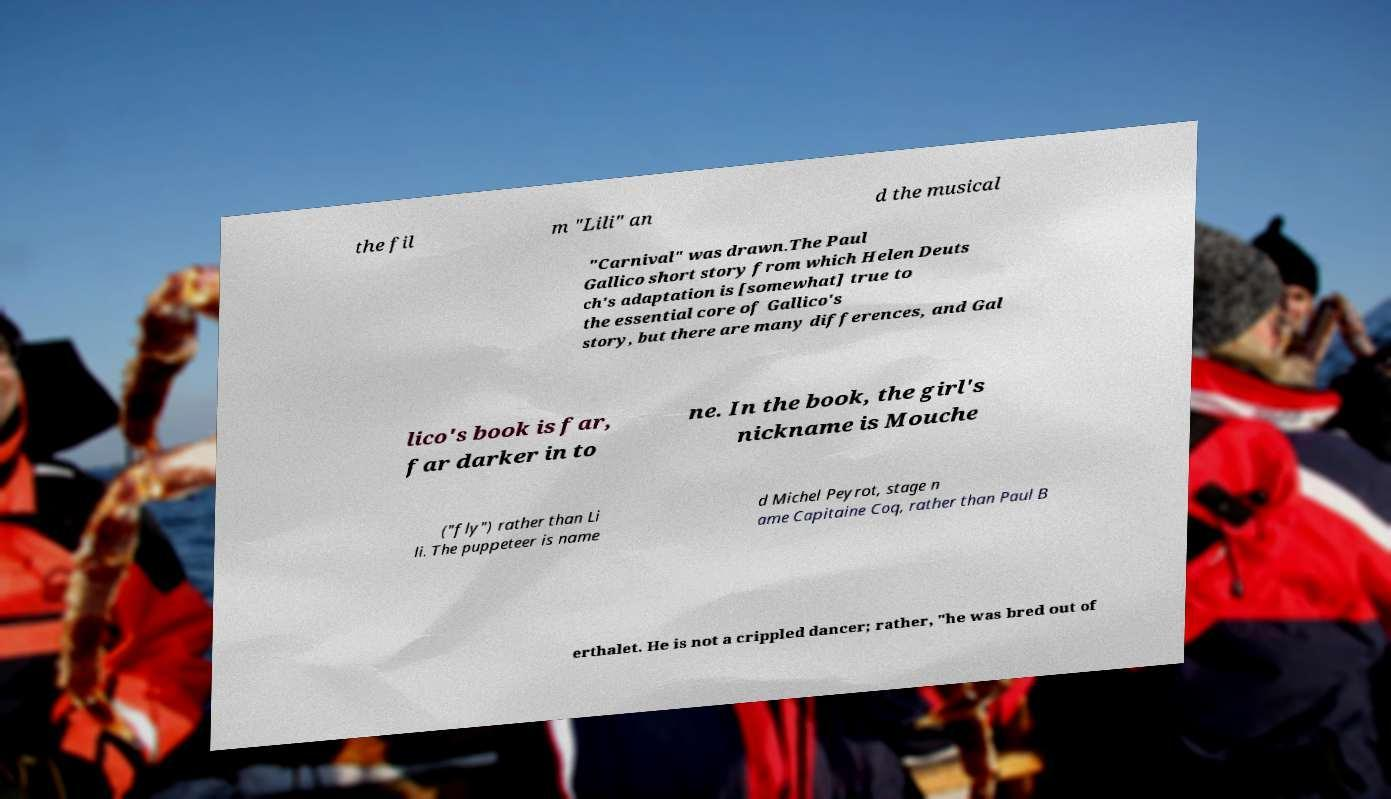Can you read and provide the text displayed in the image?This photo seems to have some interesting text. Can you extract and type it out for me? the fil m "Lili" an d the musical "Carnival" was drawn.The Paul Gallico short story from which Helen Deuts ch's adaptation is [somewhat] true to the essential core of Gallico's story, but there are many differences, and Gal lico's book is far, far darker in to ne. In the book, the girl's nickname is Mouche ("fly") rather than Li li. The puppeteer is name d Michel Peyrot, stage n ame Capitaine Coq, rather than Paul B erthalet. He is not a crippled dancer; rather, "he was bred out of 